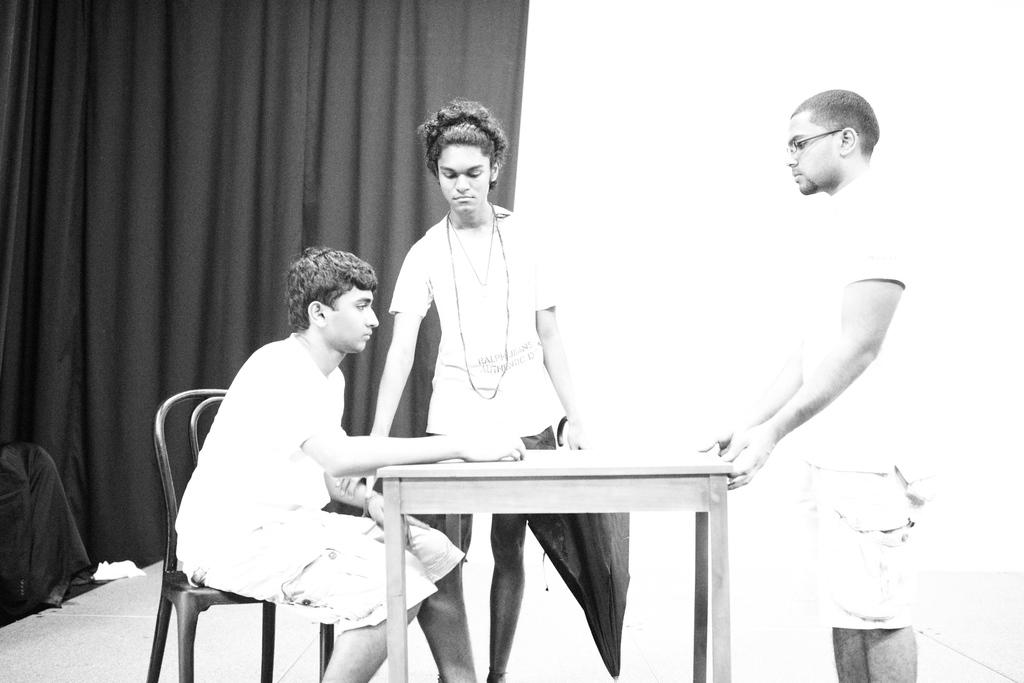How many people are present in the image? There are three persons in the image. What are the positions of the people in the image? One person is sitting in a chair, and two persons are standing. What furniture is present in the image? There is a table in the image. What can be seen at the backside of the image? There is a curtain visible at the backside of the image. What type of monkey can be seen making a discovery in the image? There is no monkey present in the image, nor is there any indication of a discovery being made. What sound can be heard during the thunderstorm in the image? There is no thunderstorm present in the image, so it is not possible to determine the sound that might be heard. 